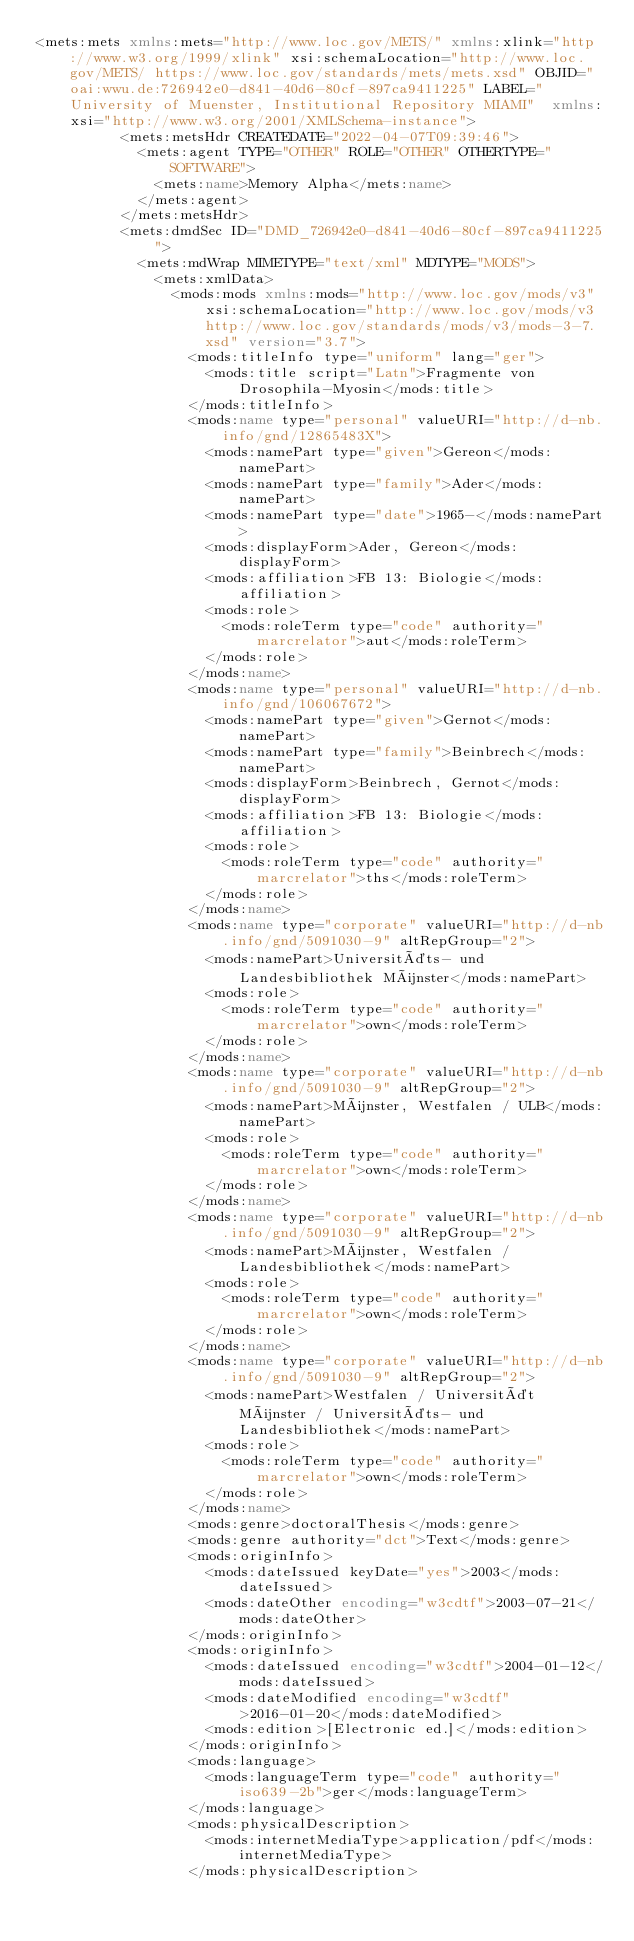Convert code to text. <code><loc_0><loc_0><loc_500><loc_500><_XML_><mets:mets xmlns:mets="http://www.loc.gov/METS/" xmlns:xlink="http://www.w3.org/1999/xlink" xsi:schemaLocation="http://www.loc.gov/METS/ https://www.loc.gov/standards/mets/mets.xsd" OBJID="oai:wwu.de:726942e0-d841-40d6-80cf-897ca9411225" LABEL="University of Muenster, Institutional Repository MIAMI"  xmlns:xsi="http://www.w3.org/2001/XMLSchema-instance">
          <mets:metsHdr CREATEDATE="2022-04-07T09:39:46">
            <mets:agent TYPE="OTHER" ROLE="OTHER" OTHERTYPE="SOFTWARE">
              <mets:name>Memory Alpha</mets:name>
            </mets:agent>
          </mets:metsHdr>
          <mets:dmdSec ID="DMD_726942e0-d841-40d6-80cf-897ca9411225">
            <mets:mdWrap MIMETYPE="text/xml" MDTYPE="MODS">
              <mets:xmlData>
                <mods:mods xmlns:mods="http://www.loc.gov/mods/v3" xsi:schemaLocation="http://www.loc.gov/mods/v3 http://www.loc.gov/standards/mods/v3/mods-3-7.xsd" version="3.7">
                  <mods:titleInfo type="uniform" lang="ger">
                    <mods:title script="Latn">Fragmente von Drosophila-Myosin</mods:title>
                  </mods:titleInfo>
                  <mods:name type="personal" valueURI="http://d-nb.info/gnd/12865483X">
                    <mods:namePart type="given">Gereon</mods:namePart>
                    <mods:namePart type="family">Ader</mods:namePart>
                    <mods:namePart type="date">1965-</mods:namePart>
                    <mods:displayForm>Ader, Gereon</mods:displayForm>
                    <mods:affiliation>FB 13: Biologie</mods:affiliation>
                    <mods:role>
                      <mods:roleTerm type="code" authority="marcrelator">aut</mods:roleTerm>
                    </mods:role>
                  </mods:name>
                  <mods:name type="personal" valueURI="http://d-nb.info/gnd/106067672">
                    <mods:namePart type="given">Gernot</mods:namePart>
                    <mods:namePart type="family">Beinbrech</mods:namePart>
                    <mods:displayForm>Beinbrech, Gernot</mods:displayForm>
                    <mods:affiliation>FB 13: Biologie</mods:affiliation>
                    <mods:role>
                      <mods:roleTerm type="code" authority="marcrelator">ths</mods:roleTerm>
                    </mods:role>
                  </mods:name>
                  <mods:name type="corporate" valueURI="http://d-nb.info/gnd/5091030-9" altRepGroup="2">
                    <mods:namePart>Universitäts- und Landesbibliothek Münster</mods:namePart>
                    <mods:role>
                      <mods:roleTerm type="code" authority="marcrelator">own</mods:roleTerm>
                    </mods:role>
                  </mods:name>
                  <mods:name type="corporate" valueURI="http://d-nb.info/gnd/5091030-9" altRepGroup="2">
                    <mods:namePart>Münster, Westfalen / ULB</mods:namePart>
                    <mods:role>
                      <mods:roleTerm type="code" authority="marcrelator">own</mods:roleTerm>
                    </mods:role>
                  </mods:name>
                  <mods:name type="corporate" valueURI="http://d-nb.info/gnd/5091030-9" altRepGroup="2">
                    <mods:namePart>Münster, Westfalen / Landesbibliothek</mods:namePart>
                    <mods:role>
                      <mods:roleTerm type="code" authority="marcrelator">own</mods:roleTerm>
                    </mods:role>
                  </mods:name>
                  <mods:name type="corporate" valueURI="http://d-nb.info/gnd/5091030-9" altRepGroup="2">
                    <mods:namePart>Westfalen / Universität Münster / Universitäts- und Landesbibliothek</mods:namePart>
                    <mods:role>
                      <mods:roleTerm type="code" authority="marcrelator">own</mods:roleTerm>
                    </mods:role>
                  </mods:name>
                  <mods:genre>doctoralThesis</mods:genre>
                  <mods:genre authority="dct">Text</mods:genre>
                  <mods:originInfo>
                    <mods:dateIssued keyDate="yes">2003</mods:dateIssued>
                    <mods:dateOther encoding="w3cdtf">2003-07-21</mods:dateOther>
                  </mods:originInfo>
                  <mods:originInfo>
                    <mods:dateIssued encoding="w3cdtf">2004-01-12</mods:dateIssued>
                    <mods:dateModified encoding="w3cdtf">2016-01-20</mods:dateModified>
                    <mods:edition>[Electronic ed.]</mods:edition>
                  </mods:originInfo>
                  <mods:language>
                    <mods:languageTerm type="code" authority="iso639-2b">ger</mods:languageTerm>
                  </mods:language>
                  <mods:physicalDescription>
                    <mods:internetMediaType>application/pdf</mods:internetMediaType>
                  </mods:physicalDescription></code> 